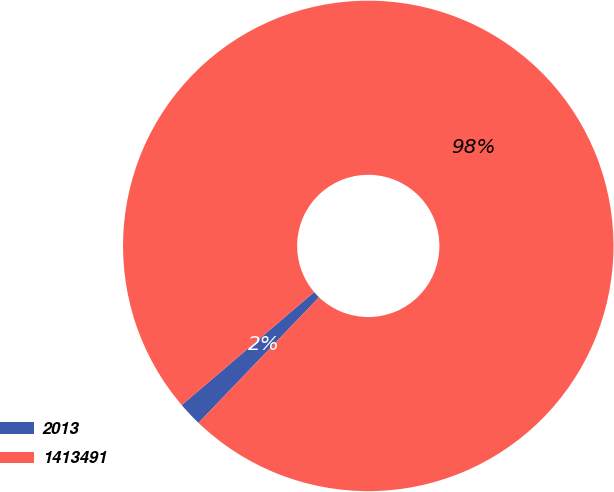<chart> <loc_0><loc_0><loc_500><loc_500><pie_chart><fcel>2013<fcel>1413491<nl><fcel>1.59%<fcel>98.41%<nl></chart> 